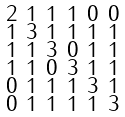<formula> <loc_0><loc_0><loc_500><loc_500>\begin{smallmatrix} 2 & 1 & 1 & 1 & 0 & 0 \\ 1 & 3 & 1 & 1 & 1 & 1 \\ 1 & 1 & 3 & 0 & 1 & 1 \\ 1 & 1 & 0 & 3 & 1 & 1 \\ 0 & 1 & 1 & 1 & 3 & 1 \\ 0 & 1 & 1 & 1 & 1 & 3 \end{smallmatrix}</formula> 